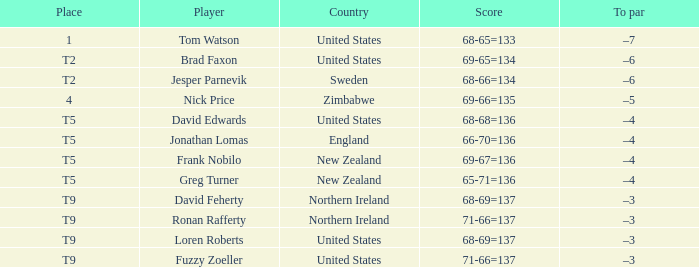In which country does the golfer occupying the top spot originate? United States. Would you be able to parse every entry in this table? {'header': ['Place', 'Player', 'Country', 'Score', 'To par'], 'rows': [['1', 'Tom Watson', 'United States', '68-65=133', '–7'], ['T2', 'Brad Faxon', 'United States', '69-65=134', '–6'], ['T2', 'Jesper Parnevik', 'Sweden', '68-66=134', '–6'], ['4', 'Nick Price', 'Zimbabwe', '69-66=135', '–5'], ['T5', 'David Edwards', 'United States', '68-68=136', '–4'], ['T5', 'Jonathan Lomas', 'England', '66-70=136', '–4'], ['T5', 'Frank Nobilo', 'New Zealand', '69-67=136', '–4'], ['T5', 'Greg Turner', 'New Zealand', '65-71=136', '–4'], ['T9', 'David Feherty', 'Northern Ireland', '68-69=137', '–3'], ['T9', 'Ronan Rafferty', 'Northern Ireland', '71-66=137', '–3'], ['T9', 'Loren Roberts', 'United States', '68-69=137', '–3'], ['T9', 'Fuzzy Zoeller', 'United States', '71-66=137', '–3']]} 